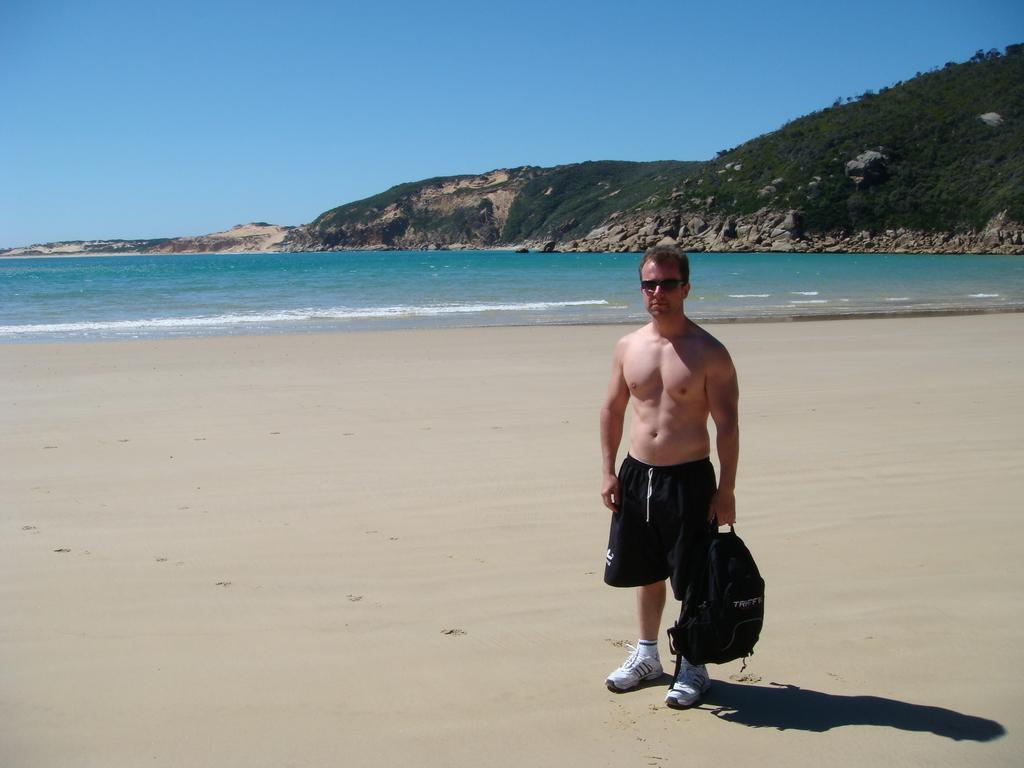Could you give a brief overview of what you see in this image? In this picture I can see a man standing and holding a bag in his hand and I can see water, few trees on the hill and a blue sky. 